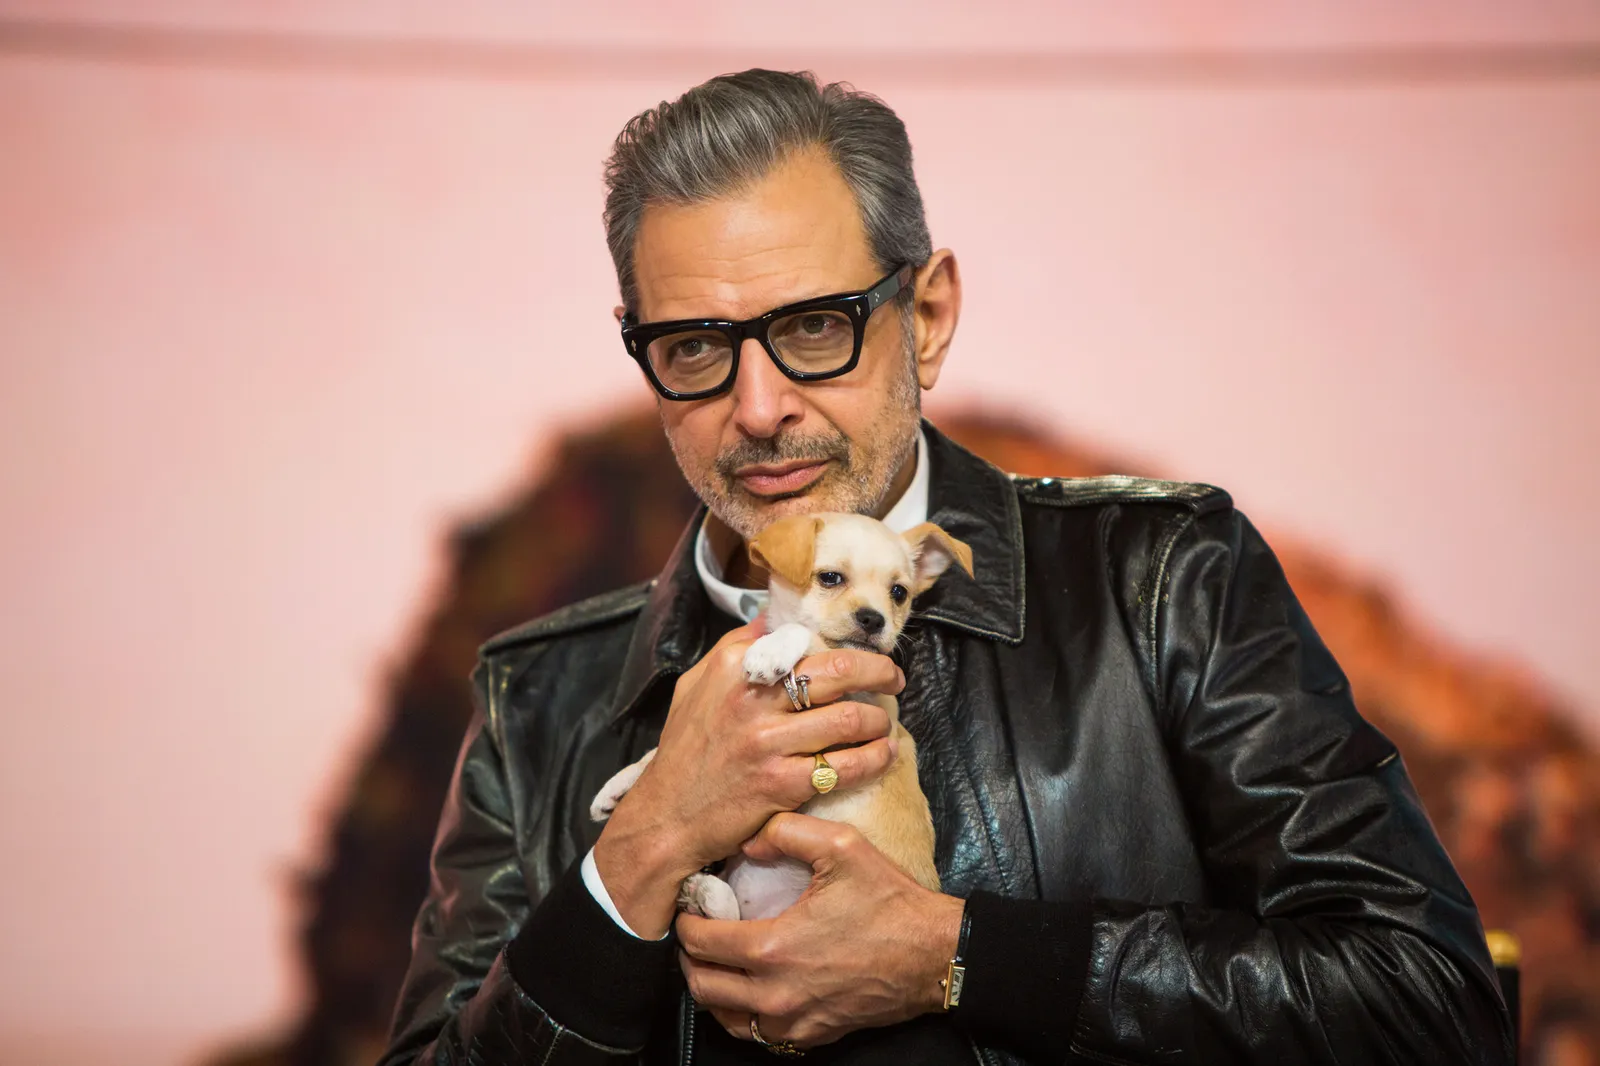Imagine the puppy in the image could speak for a moment. What would it say? If the puppy could speak, it might say, 'Thank you for rescuing me. Your arms are warm and safe. I love this moment with you, and I feel so happy and cared for. Can we stay like this forever?' What adventures could they go on together? The pair could embark on various adventures, from early morning hikes up mountains, discovering hidden trails and secret waterfalls, to cozy evenings by the fireplace, reading scripts and sharing stories. They might travel across scenic landscapes, the actor taking breaks between shoots to show the puppy the wonders of the world — the vast oceans, dense forests, and vibrant cities. Everywhere they go, they bring joy to those they meet, their bond a testament to the simple power of companionship and love. Create a whimsical scenario involving a magical element. One evening, as the actor and the puppy rested under the stars, a gentle moonbeam touched the puppy's nose, granting it the ability to speak for 24 hours. Awestruck, they conversed about dreams and desires. Together, they discovered an enchanted forest where the puppy’s newfound voice could summon ancient forest spirits. These spirits bestowed wisdom and secrets of the ages upon them, revealing hidden pathways and magical creatures that transformed their journey into an ethereal quest, filled with marvel and endless wonder. 